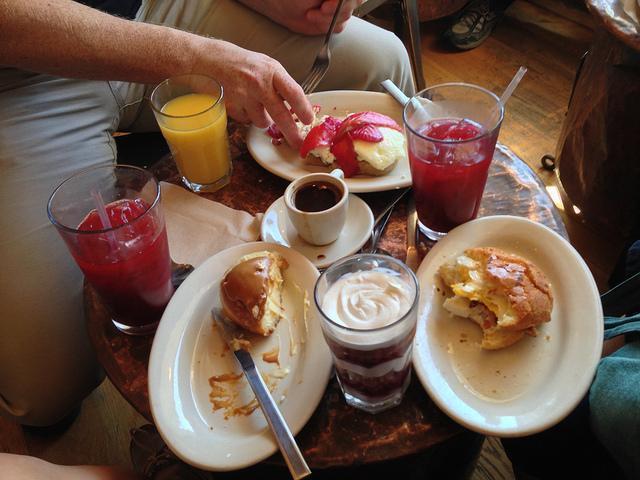Is the given caption "The dining table is behind the person." fitting for the image?
Answer yes or no. No. 